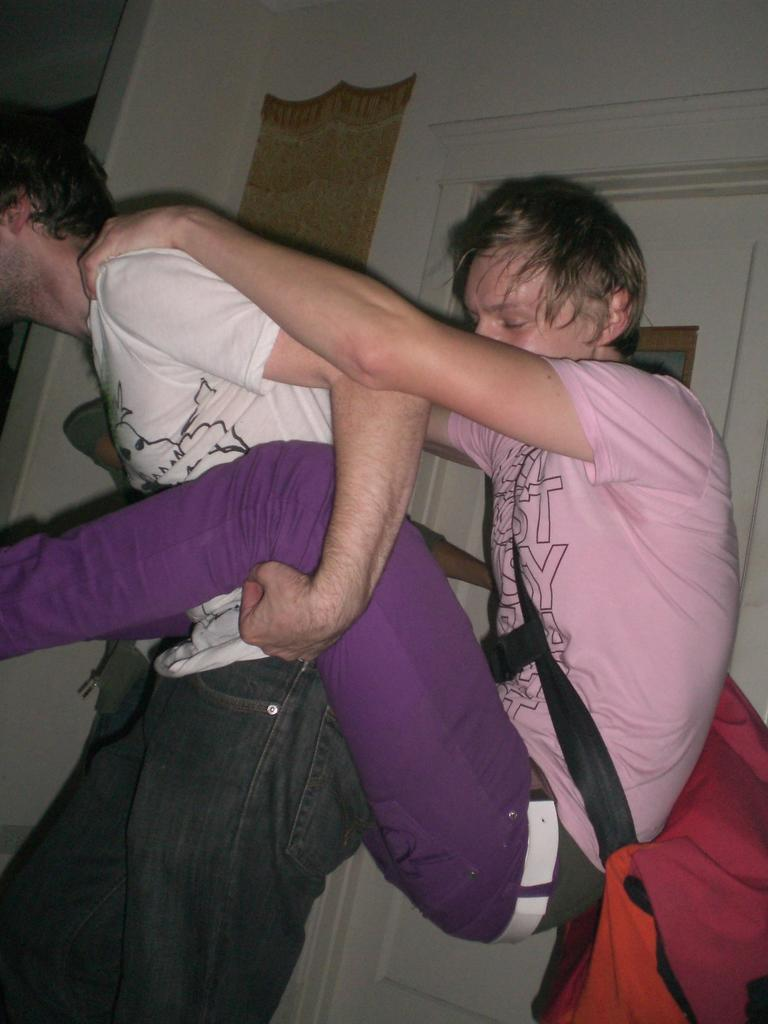What is happening between the two people in the image? There is a person carrying another person in the image. What can be seen in the background of the image? There is a door in the background of the image. What is the setting of the image? There is a wall in the image, which suggests an indoor setting. What type of crops is the farmer harvesting in the image? There is no farmer or crops present in the image; it features a person carrying another person with a door and wall in the background. How many legs does the sea have in the image? There is no sea present in the image, so it is not possible to determine the number of legs it might have. 